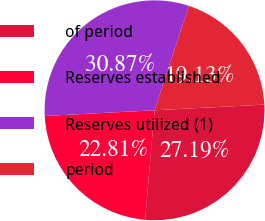<chart> <loc_0><loc_0><loc_500><loc_500><pie_chart><fcel>of period<fcel>Reserves established<fcel>Reserves utilized (1)<fcel>period<nl><fcel>27.19%<fcel>22.81%<fcel>30.87%<fcel>19.13%<nl></chart> 